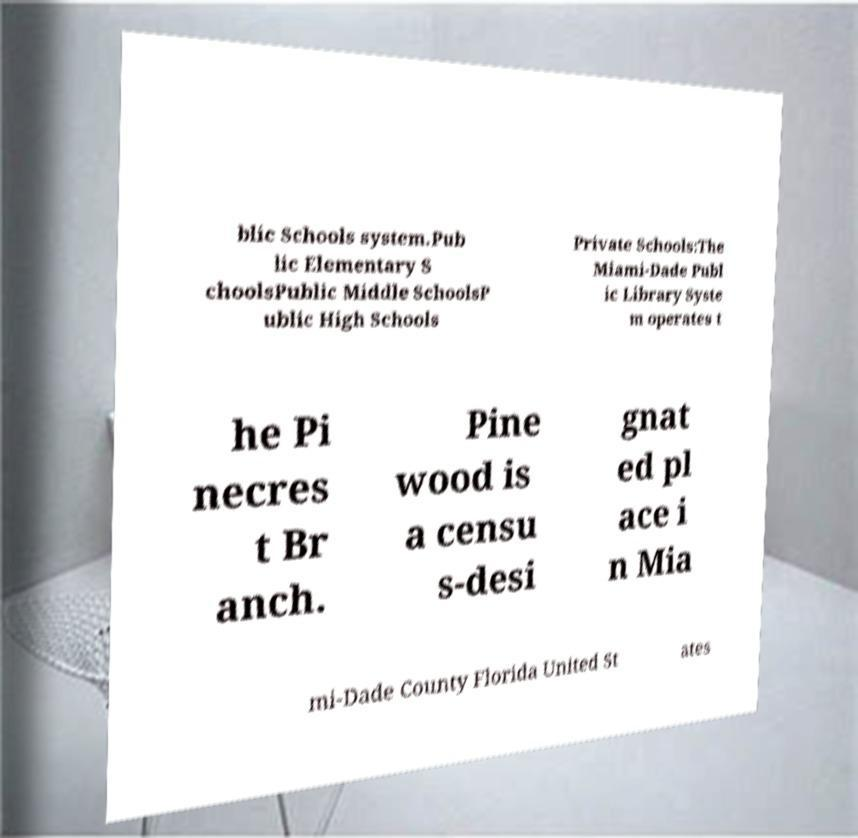For documentation purposes, I need the text within this image transcribed. Could you provide that? blic Schools system.Pub lic Elementary S choolsPublic Middle SchoolsP ublic High Schools Private Schools:The Miami-Dade Publ ic Library Syste m operates t he Pi necres t Br anch. Pine wood is a censu s-desi gnat ed pl ace i n Mia mi-Dade County Florida United St ates 